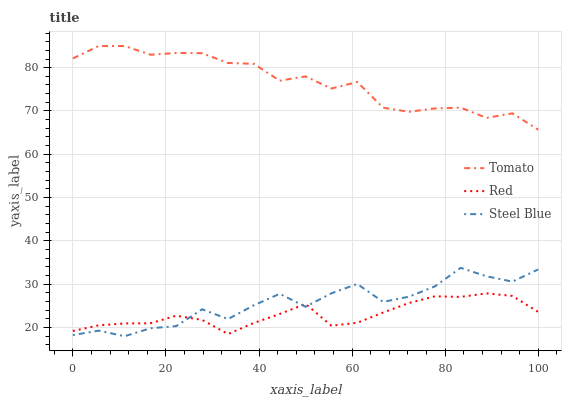Does Steel Blue have the minimum area under the curve?
Answer yes or no. No. Does Steel Blue have the maximum area under the curve?
Answer yes or no. No. Is Steel Blue the smoothest?
Answer yes or no. No. Is Red the roughest?
Answer yes or no. No. Does Red have the lowest value?
Answer yes or no. No. Does Steel Blue have the highest value?
Answer yes or no. No. Is Steel Blue less than Tomato?
Answer yes or no. Yes. Is Tomato greater than Steel Blue?
Answer yes or no. Yes. Does Steel Blue intersect Tomato?
Answer yes or no. No. 